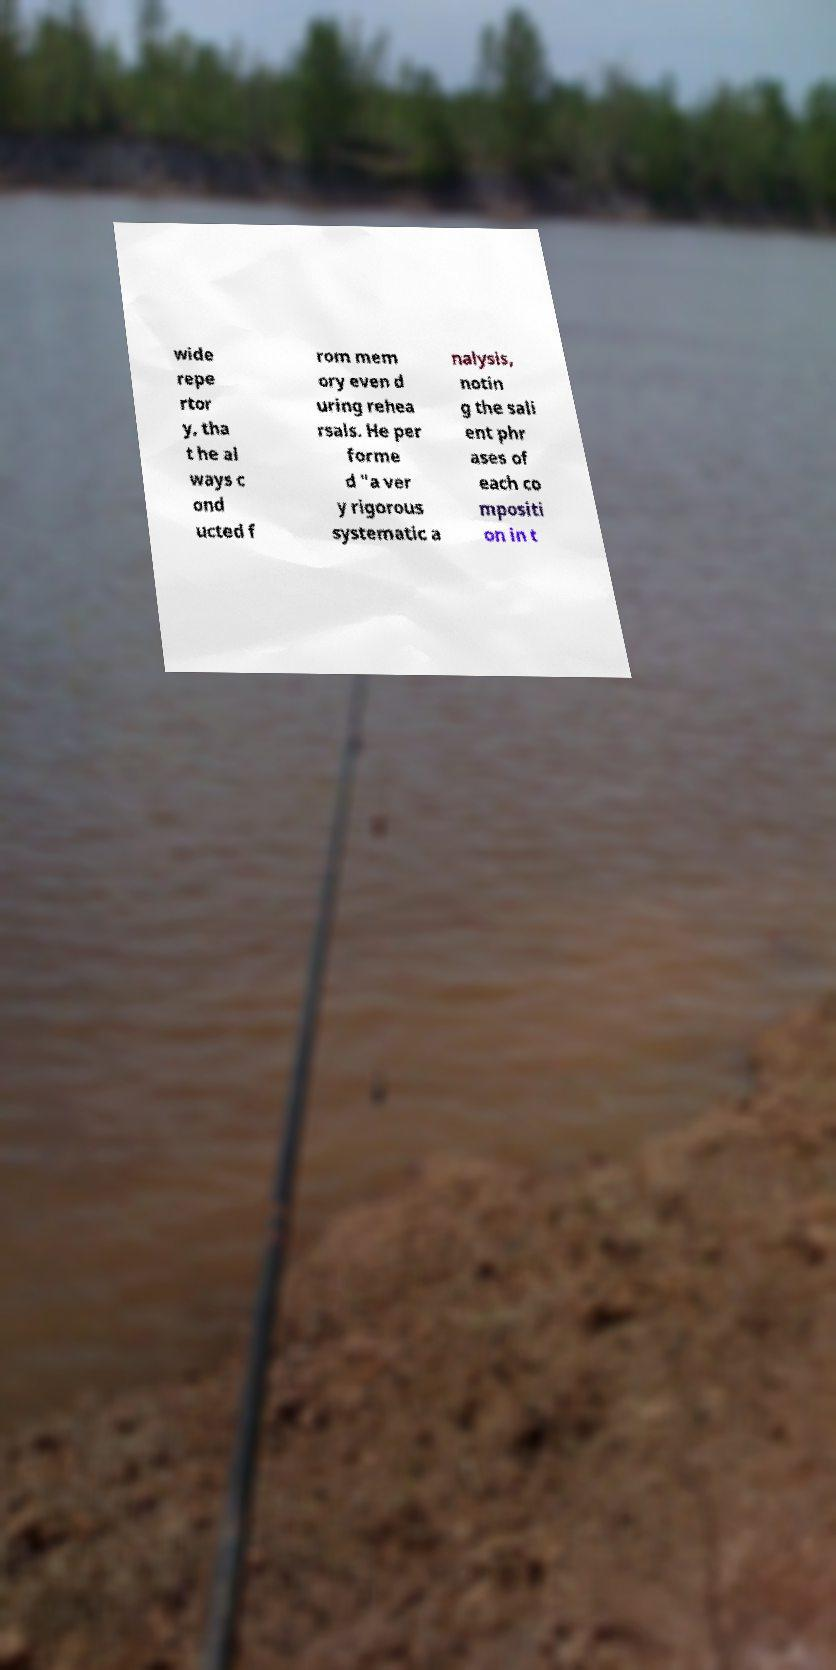What messages or text are displayed in this image? I need them in a readable, typed format. wide repe rtor y, tha t he al ways c ond ucted f rom mem ory even d uring rehea rsals. He per forme d "a ver y rigorous systematic a nalysis, notin g the sali ent phr ases of each co mpositi on in t 